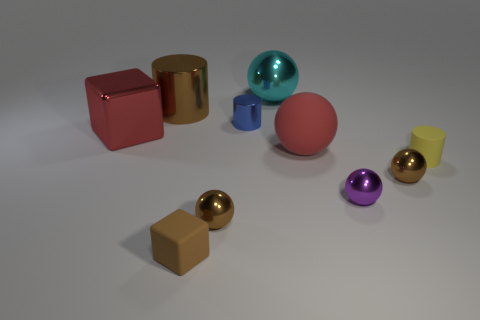Subtract all yellow spheres. Subtract all brown cylinders. How many spheres are left? 5 Subtract all blocks. How many objects are left? 8 Subtract 0 red cylinders. How many objects are left? 10 Subtract all brown rubber cubes. Subtract all tiny yellow objects. How many objects are left? 8 Add 5 brown matte cubes. How many brown matte cubes are left? 6 Add 9 tiny yellow rubber things. How many tiny yellow rubber things exist? 10 